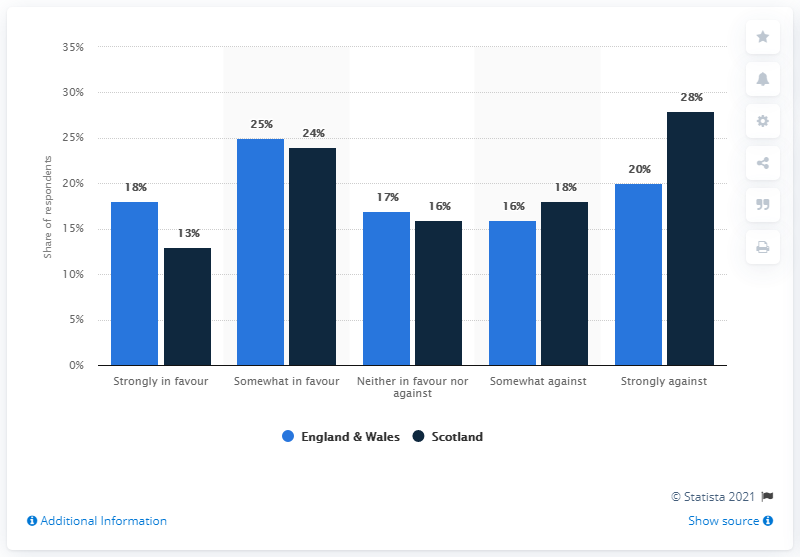Indicate a few pertinent items in this graphic. Scotland has a smaller population than Great Britain and is the country with fewer nuclear weapons in regards to nuclear weapons. 